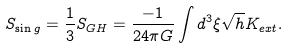<formula> <loc_0><loc_0><loc_500><loc_500>S _ { \sin g } = { \frac { 1 } { 3 } } S _ { G H } = { \frac { - 1 } { 2 4 \pi G } } \int d ^ { 3 } \xi \sqrt { h } K _ { e x t } .</formula> 